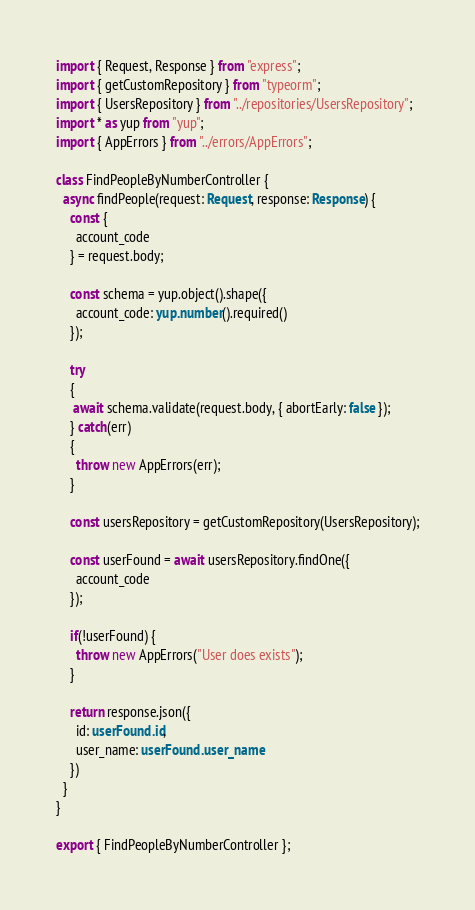<code> <loc_0><loc_0><loc_500><loc_500><_TypeScript_>import { Request, Response } from "express";
import { getCustomRepository } from "typeorm";
import { UsersRepository } from "../repositories/UsersRepository";
import * as yup from "yup";
import { AppErrors } from "../errors/AppErrors";

class FindPeopleByNumberController {
  async findPeople(request: Request, response: Response) {
    const {
      account_code      
    } = request.body;

    const schema = yup.object().shape({
      account_code: yup.number().required()
    });

    try 
    {
     await schema.validate(request.body, { abortEarly: false });
    } catch(err) 
    {
      throw new AppErrors(err);
    }

    const usersRepository = getCustomRepository(UsersRepository);

    const userFound = await usersRepository.findOne({
      account_code
    });

    if(!userFound) {
      throw new AppErrors("User does exists");      
    }

    return response.json({
      id: userFound.id,
      user_name: userFound.user_name      
    })
  }
}

export { FindPeopleByNumberController };</code> 